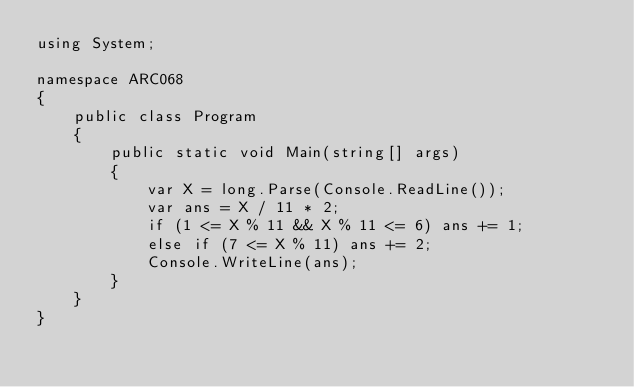Convert code to text. <code><loc_0><loc_0><loc_500><loc_500><_C#_>using System;

namespace ARC068
{
    public class Program
    {
        public static void Main(string[] args)
        {
            var X = long.Parse(Console.ReadLine());
            var ans = X / 11 * 2;
            if (1 <= X % 11 && X % 11 <= 6) ans += 1;
            else if (7 <= X % 11) ans += 2;
            Console.WriteLine(ans);
        }
    }
}</code> 